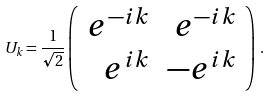Convert formula to latex. <formula><loc_0><loc_0><loc_500><loc_500>U _ { k } = \frac { 1 } { \sqrt { 2 } } \left ( \begin{array} { r r } e ^ { - i k } & e ^ { - i k } \\ e ^ { i k } & - e ^ { i k } \\ \end{array} \right ) \, .</formula> 